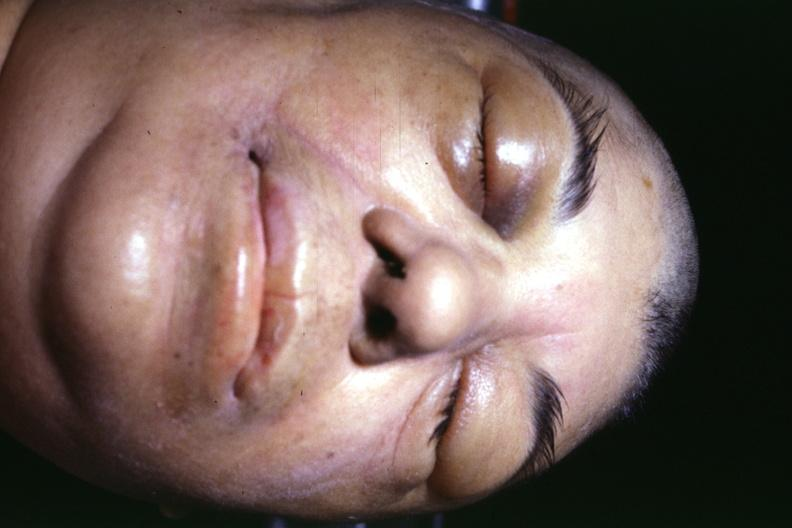what does this image show?
Answer the question using a single word or phrase. Jaundice due to terminal alcoholic cirrhosis with shock and typical facial appearance of edema due to generalized capillary permeability increase or shock 